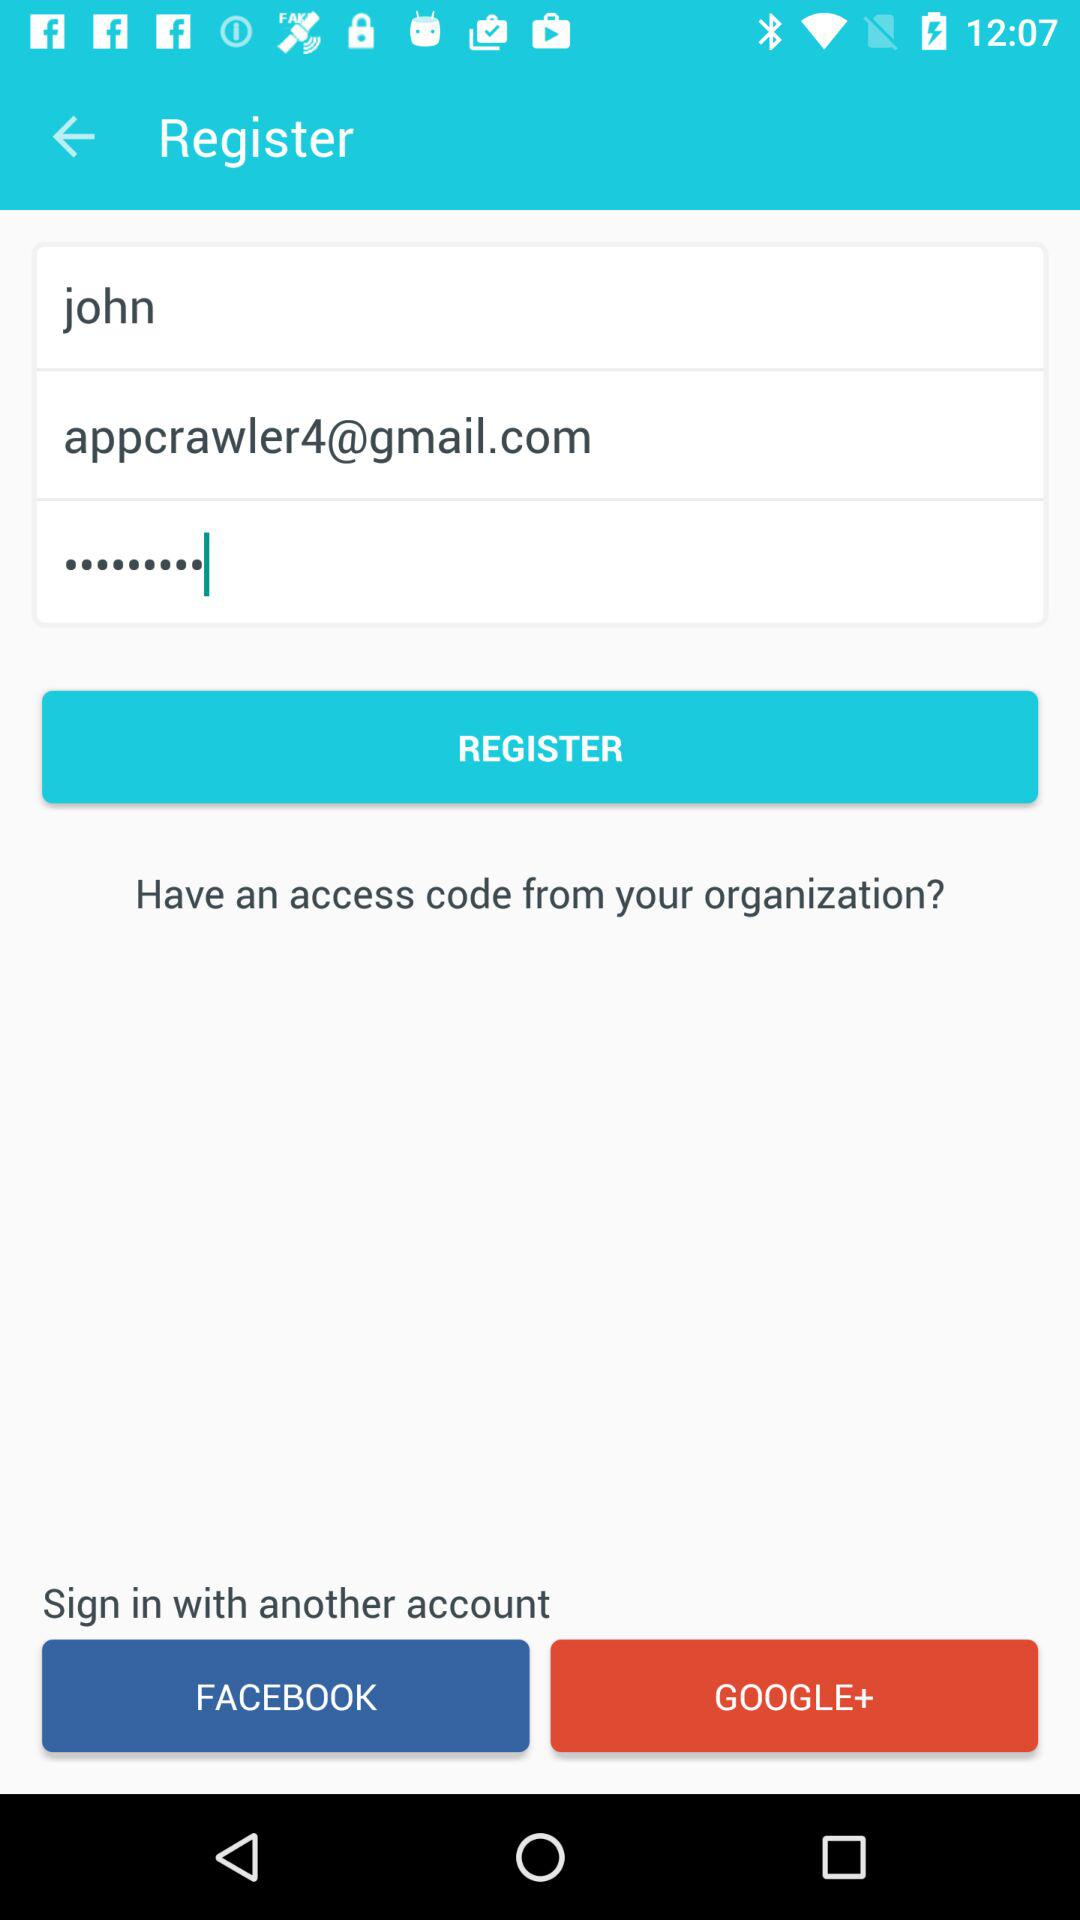What is the user name? The user name is John. 